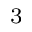Convert formula to latex. <formula><loc_0><loc_0><loc_500><loc_500>_ { 3 }</formula> 